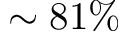Convert formula to latex. <formula><loc_0><loc_0><loc_500><loc_500>\sim 8 1 \%</formula> 